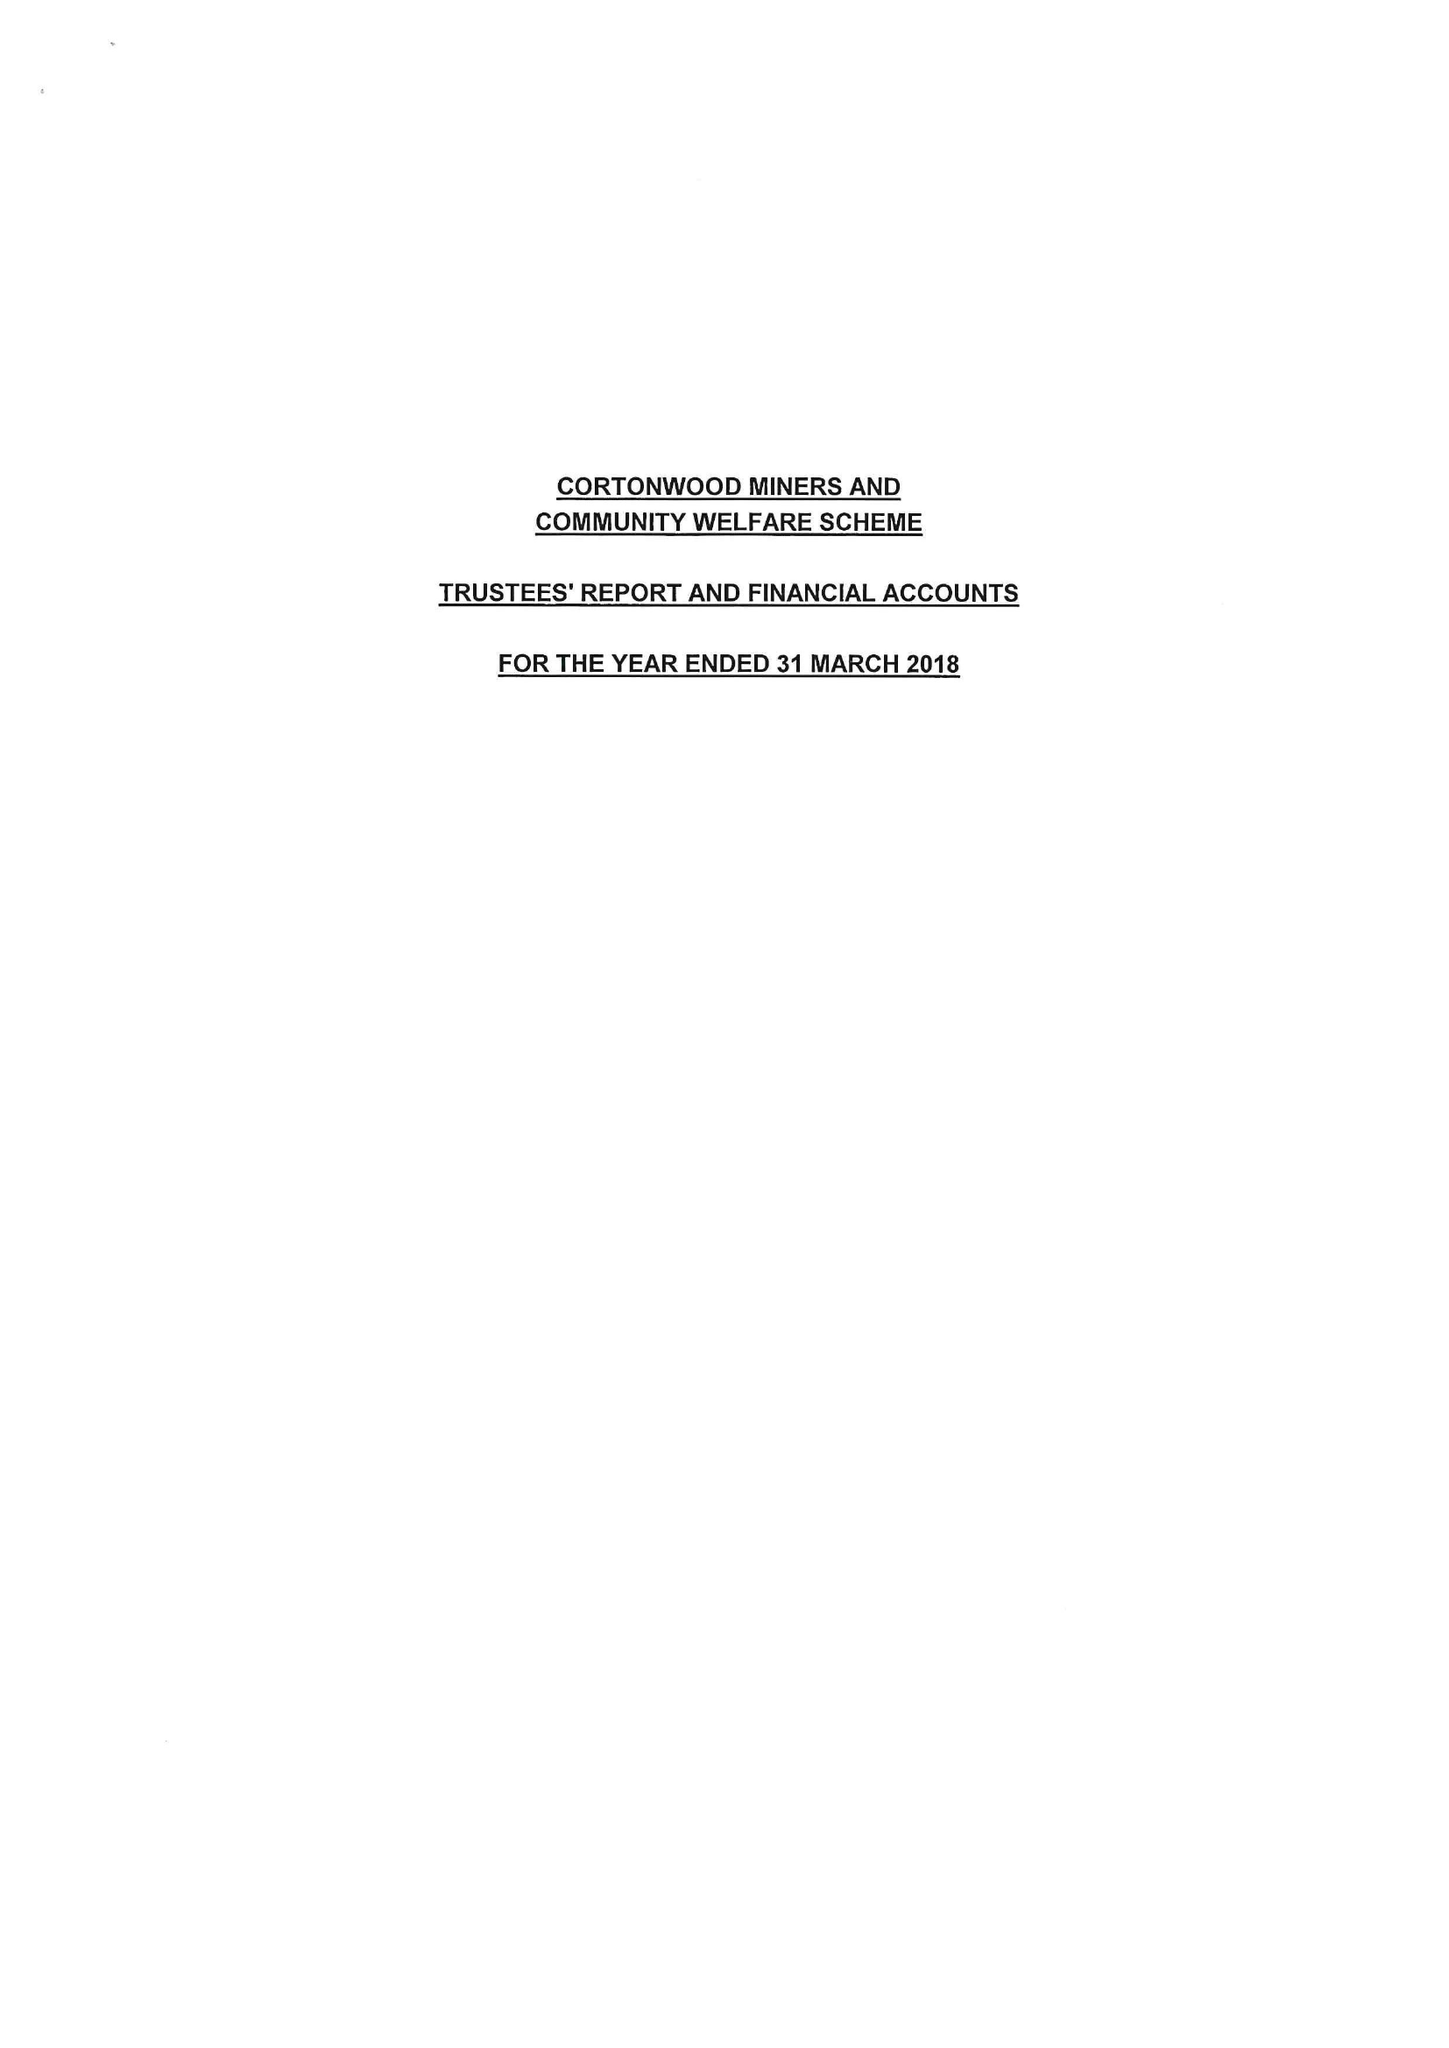What is the value for the charity_number?
Answer the question using a single word or phrase. 523521 